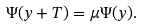<formula> <loc_0><loc_0><loc_500><loc_500>\Psi ( y + T ) = \mu \Psi ( y ) .</formula> 